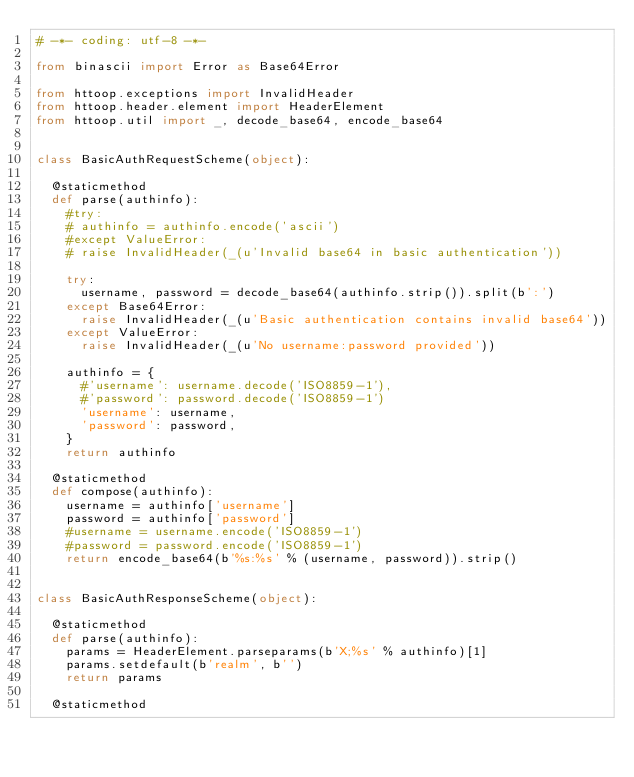Convert code to text. <code><loc_0><loc_0><loc_500><loc_500><_Python_># -*- coding: utf-8 -*-

from binascii import Error as Base64Error

from httoop.exceptions import InvalidHeader
from httoop.header.element import HeaderElement
from httoop.util import _, decode_base64, encode_base64


class BasicAuthRequestScheme(object):

	@staticmethod
	def parse(authinfo):
		#try:
		#	authinfo = authinfo.encode('ascii')
		#except ValueError:
		#	raise InvalidHeader(_(u'Invalid base64 in basic authentication'))

		try:
			username, password = decode_base64(authinfo.strip()).split(b':')
		except Base64Error:
			raise InvalidHeader(_(u'Basic authentication contains invalid base64'))
		except ValueError:
			raise InvalidHeader(_(u'No username:password provided'))

		authinfo = {
			#'username': username.decode('ISO8859-1'),
			#'password': password.decode('ISO8859-1')
			'username': username,
			'password': password,
		}
		return authinfo

	@staticmethod
	def compose(authinfo):
		username = authinfo['username']
		password = authinfo['password']
		#username = username.encode('ISO8859-1')
		#password = password.encode('ISO8859-1')
		return encode_base64(b'%s:%s' % (username, password)).strip()


class BasicAuthResponseScheme(object):

	@staticmethod
	def parse(authinfo):
		params = HeaderElement.parseparams(b'X;%s' % authinfo)[1]
		params.setdefault(b'realm', b'')
		return params

	@staticmethod</code> 